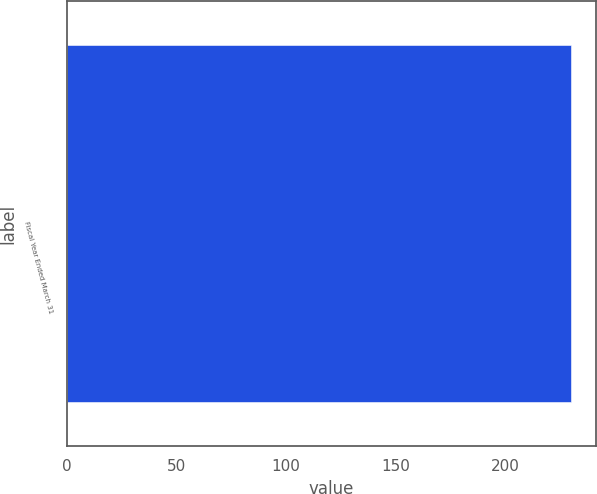<chart> <loc_0><loc_0><loc_500><loc_500><bar_chart><fcel>Fiscal Year Ended March 31<nl><fcel>230<nl></chart> 